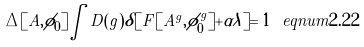Convert formula to latex. <formula><loc_0><loc_0><loc_500><loc_500>\Delta [ A , \phi _ { 0 } ] \int D ( g ) \delta [ F [ A ^ { g } , \phi _ { 0 } ^ { g } ] + \alpha \lambda ] = 1 \ e q n u m { 2 . 2 2 }</formula> 